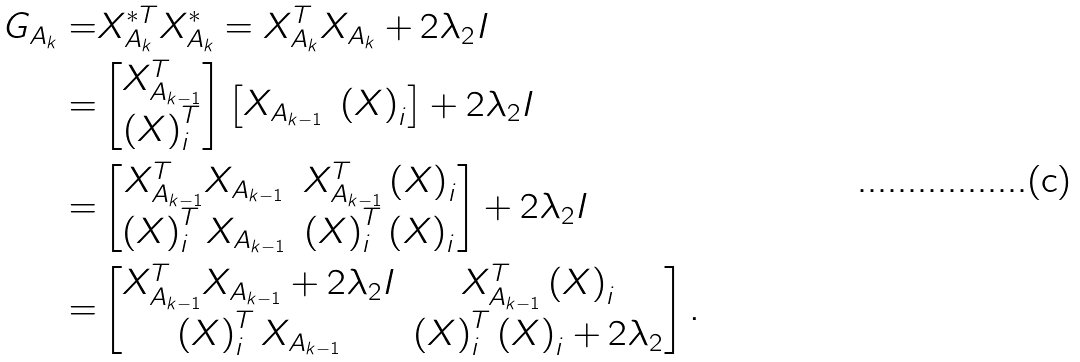Convert formula to latex. <formula><loc_0><loc_0><loc_500><loc_500>G _ { A _ { k } } = & X ^ { * T } _ { A _ { k } } X ^ { * } _ { A _ { k } } = X ^ { T } _ { A _ { k } } X _ { A _ { k } } + 2 \lambda _ { 2 } I \\ = & \begin{bmatrix} X ^ { T } _ { A _ { k - 1 } } \\ \left ( X \right ) _ { i } ^ { T } \\ \end{bmatrix} \begin{bmatrix} X _ { A _ { k - 1 } } & \left ( X \right ) _ { i } \\ \end{bmatrix} + 2 \lambda _ { 2 } I \\ = & \begin{bmatrix} X ^ { T } _ { A _ { k - 1 } } X _ { A _ { k - 1 } } & X ^ { T } _ { A _ { k - 1 } } \left ( X \right ) _ { i } \\ \left ( X \right ) _ { i } ^ { T } X _ { A _ { k - 1 } } & \left ( X \right ) _ { i } ^ { T } \left ( X \right ) _ { i } \\ \end{bmatrix} + 2 \lambda _ { 2 } I \\ = & \begin{bmatrix} X ^ { T } _ { A _ { k - 1 } } X _ { A _ { k - 1 } } + 2 \lambda _ { 2 } I & X ^ { T } _ { A _ { k - 1 } } \left ( X \right ) _ { i } \\ \left ( X \right ) _ { i } ^ { T } X _ { A _ { k - 1 } } & \left ( X \right ) _ { i } ^ { T } \left ( X \right ) _ { i } + 2 \lambda _ { 2 } \\ \end{bmatrix} .</formula> 